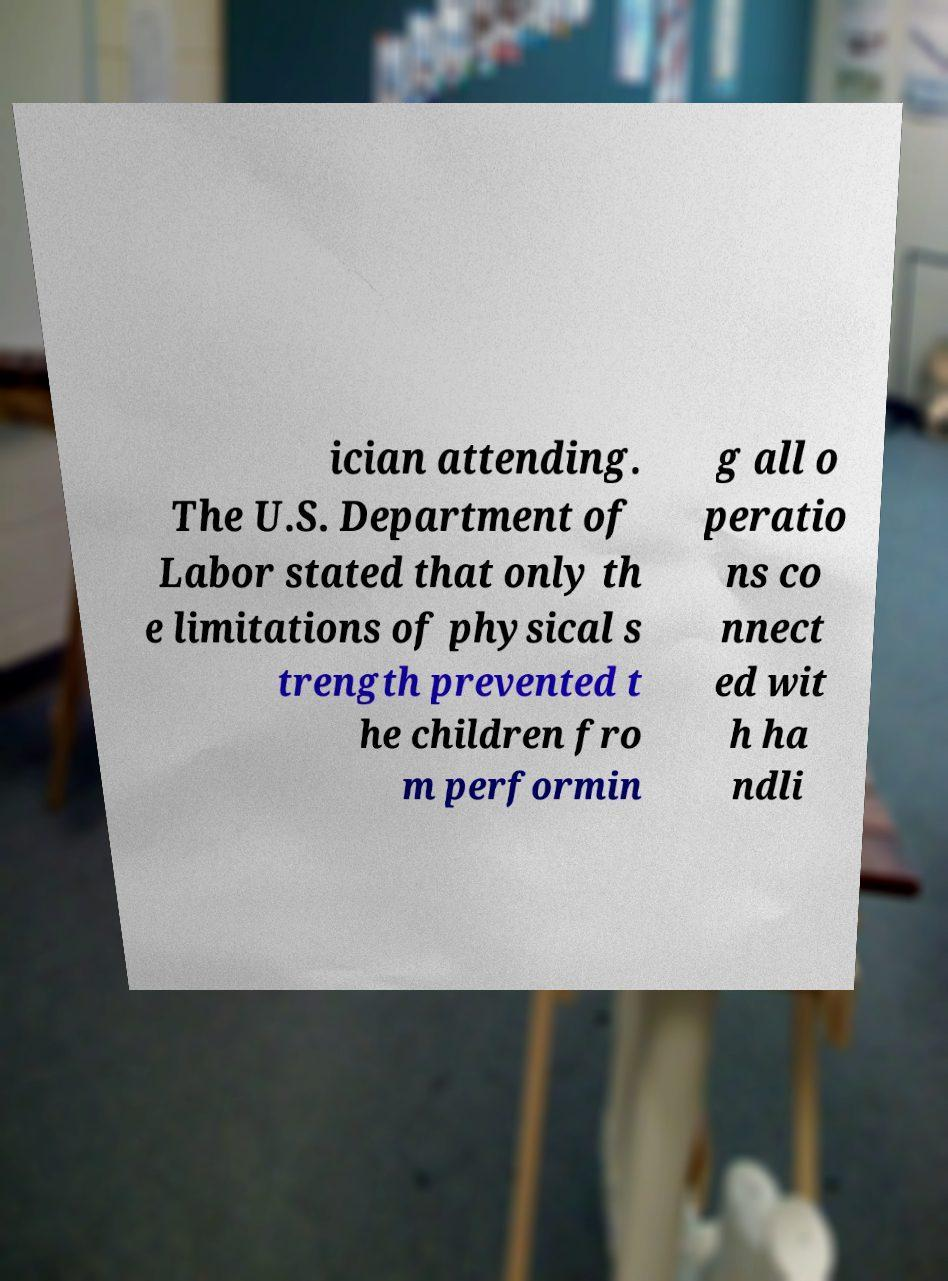What messages or text are displayed in this image? I need them in a readable, typed format. ician attending. The U.S. Department of Labor stated that only th e limitations of physical s trength prevented t he children fro m performin g all o peratio ns co nnect ed wit h ha ndli 